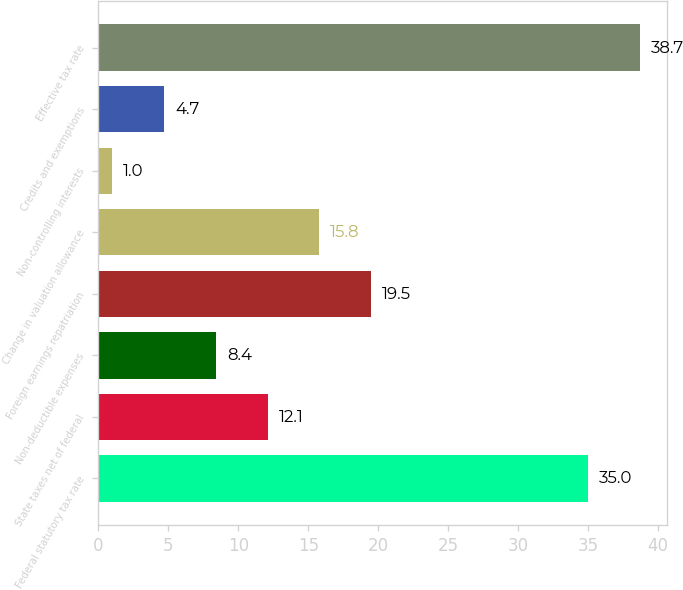<chart> <loc_0><loc_0><loc_500><loc_500><bar_chart><fcel>Federal statutory tax rate<fcel>State taxes net of federal<fcel>Non-deductible expenses<fcel>Foreign earnings repatriation<fcel>Change in valuation allowance<fcel>Non-controlling interests<fcel>Credits and exemptions<fcel>Effective tax rate<nl><fcel>35<fcel>12.1<fcel>8.4<fcel>19.5<fcel>15.8<fcel>1<fcel>4.7<fcel>38.7<nl></chart> 